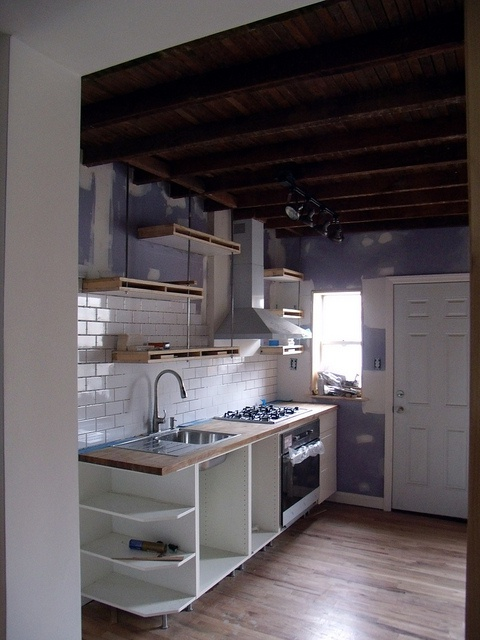Describe the objects in this image and their specific colors. I can see oven in black and gray tones and sink in black, gray, and darkgray tones in this image. 